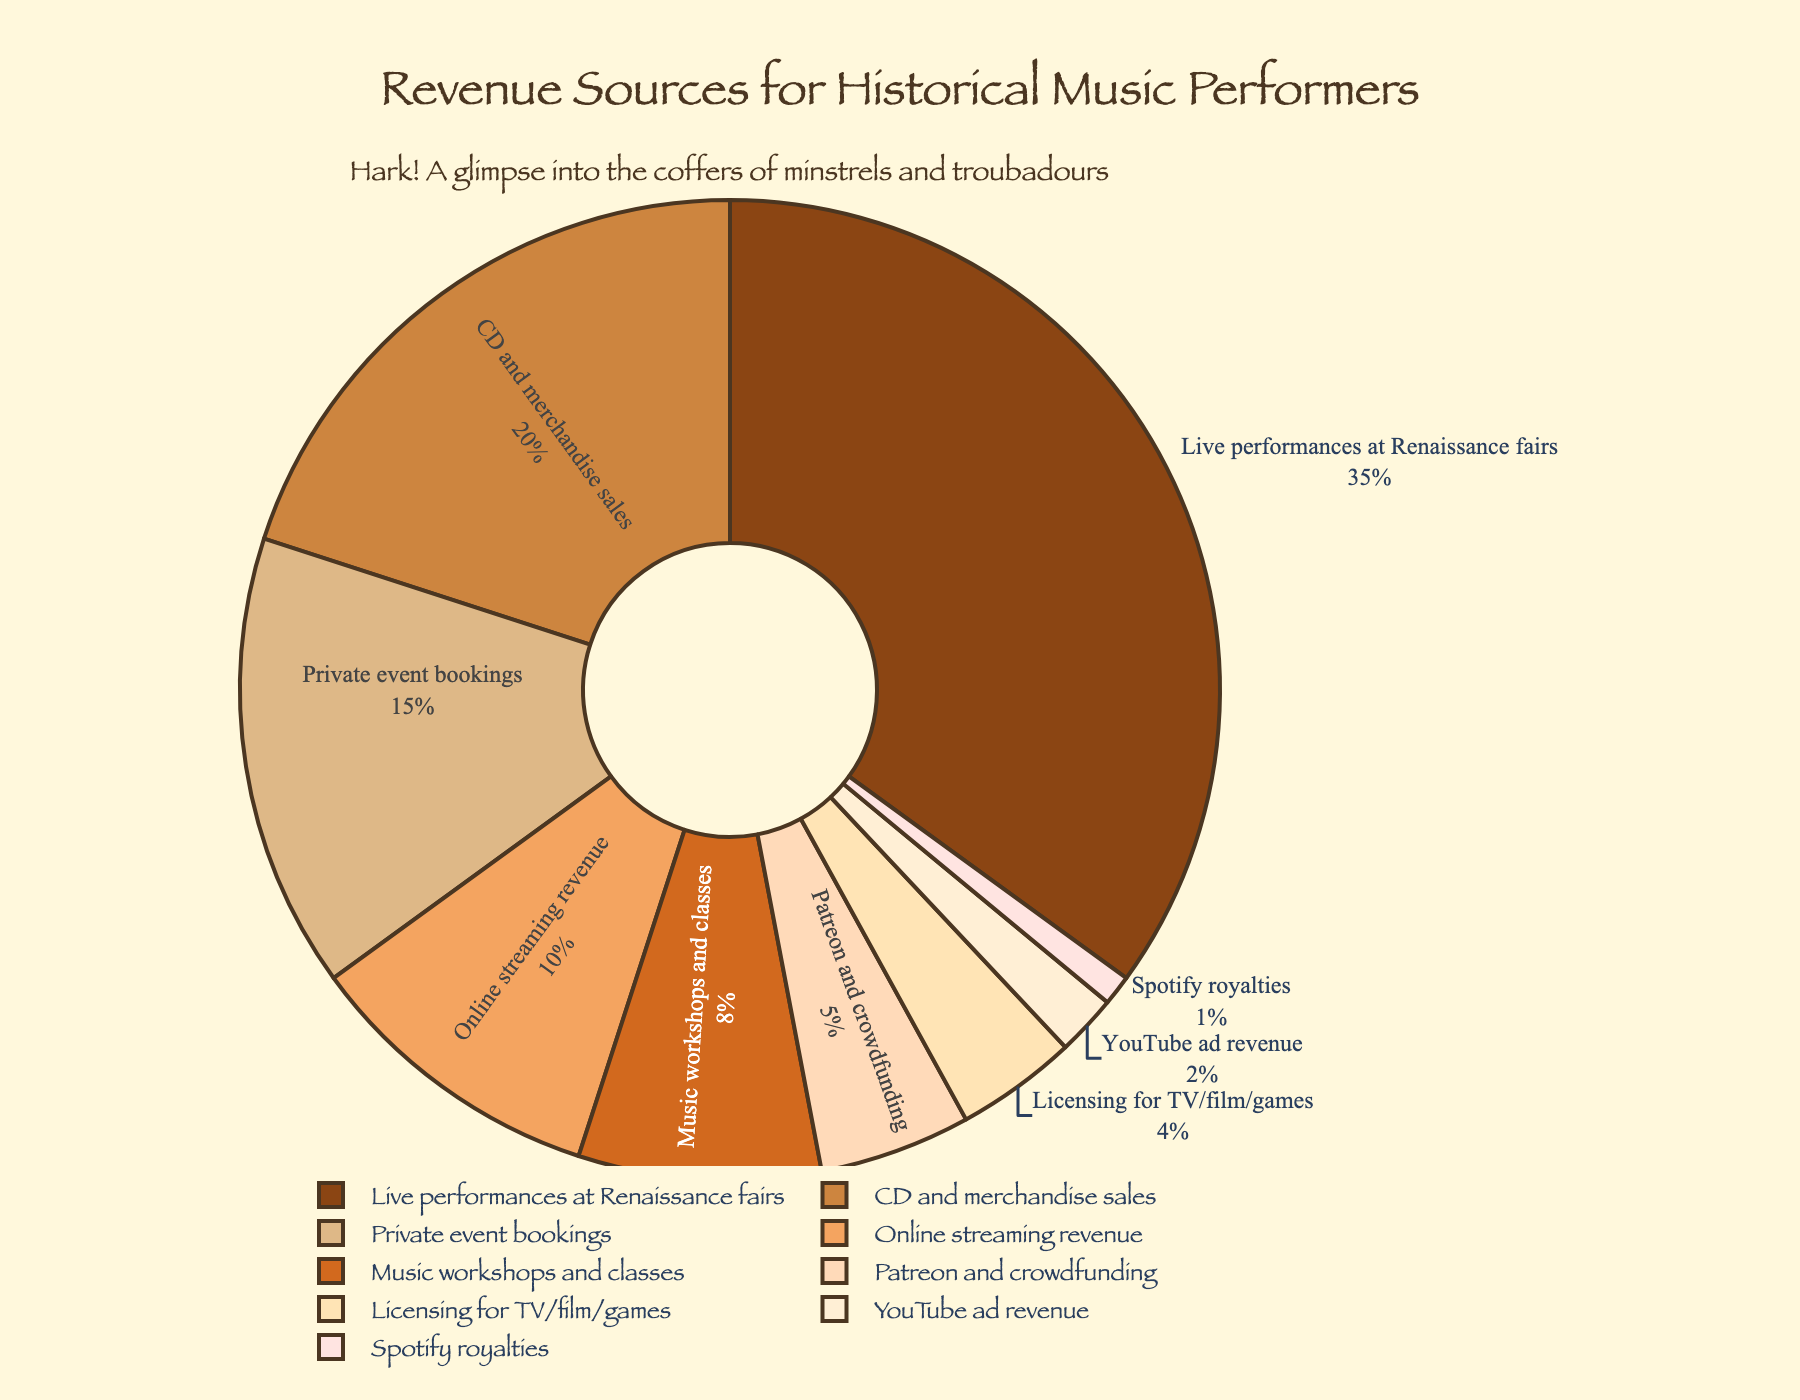Which category contributes the highest percentage to the revenue for historical music performers? The largest segment on the pie chart represents the highest percentage, which is for "Live performances at Renaissance fairs" at 35%.
Answer: Live performances at Renaissance fairs What is the combined percentage of revenue from "Private event bookings" and "Music workshops and classes"? Identify the percentages for "Private event bookings" (15%) and "Music workshops and classes" (8%), then add them together: 15% + 8% = 23%.
Answer: 23% Which revenue source has a greater percentage, "CD and merchandise sales" or "Online streaming revenue"? Compare the two percentages: "CD and merchandise sales" is 20% and "Online streaming revenue" is 10%. 20% is greater than 10%.
Answer: CD and merchandise sales What is the difference in percentage between "Patreon and crowdfunding" and "Licensing for TV/film/games"? Identify the percentages for "Patreon and crowdfunding" (5%) and "Licensing for TV/film/games" (4%), then subtract 4% from 5% to get the difference: 5% - 4% = 1%.
Answer: 1% What is the combined percentage of revenue that comes from all sources other than "Live performances at Renaissance fairs"? The total percentage for all sources is 100%. Subtract the percentage for "Live performances at Renaissance fairs" (35%) from 100%: 100% - 35% = 65%.
Answer: 65% Which category contributes less than 5% to the revenue? Identify the categories with percentages below 5%, which are "Licensing for TV/film/games" (4%), "YouTube ad revenue" (2%), and "Spotify royalties" (1%).
Answer: Licensing for TV/film/games, YouTube ad revenue, Spotify royalties Which segment is represented by the lightest shade in the color palette? The lightest shade (close to white) represents the smallest percentage, which visually corresponds to "Spotify royalties" at 1%.
Answer: Spotify royalties How many revenue sources contribute 10% or more to the total revenue? Identify and count the sources with percentages 10% or more: "Live performances at Renaissance fairs" (35%), "CD and merchandise sales" (20%), "Private event bookings" (15%), and "Online streaming revenue" (10%). There are 4 such sources.
Answer: 4 What is the sum of percentages for the three smallest revenue sources? Identify the smallest sources: "Spotify royalties" (1%), "YouTube ad revenue" (2%), and "Licensing for TV/film/games" (4%). Add these percentages: 1% + 2% + 4% = 7%.
Answer: 7% 